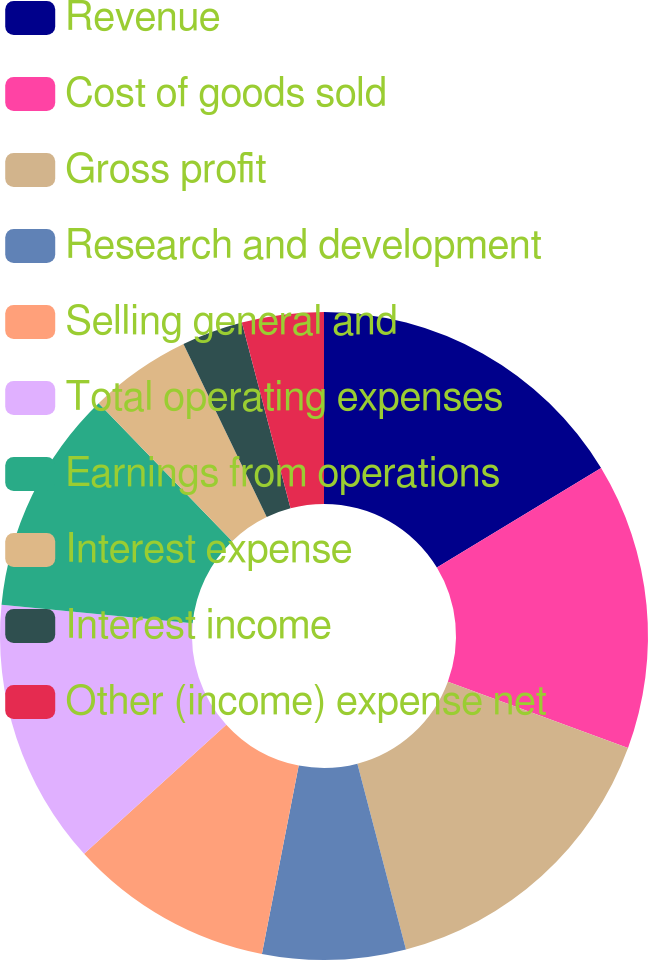Convert chart to OTSL. <chart><loc_0><loc_0><loc_500><loc_500><pie_chart><fcel>Revenue<fcel>Cost of goods sold<fcel>Gross profit<fcel>Research and development<fcel>Selling general and<fcel>Total operating expenses<fcel>Earnings from operations<fcel>Interest expense<fcel>Interest income<fcel>Other (income) expense net<nl><fcel>16.33%<fcel>14.29%<fcel>15.31%<fcel>7.14%<fcel>10.2%<fcel>13.27%<fcel>11.22%<fcel>5.1%<fcel>3.06%<fcel>4.08%<nl></chart> 